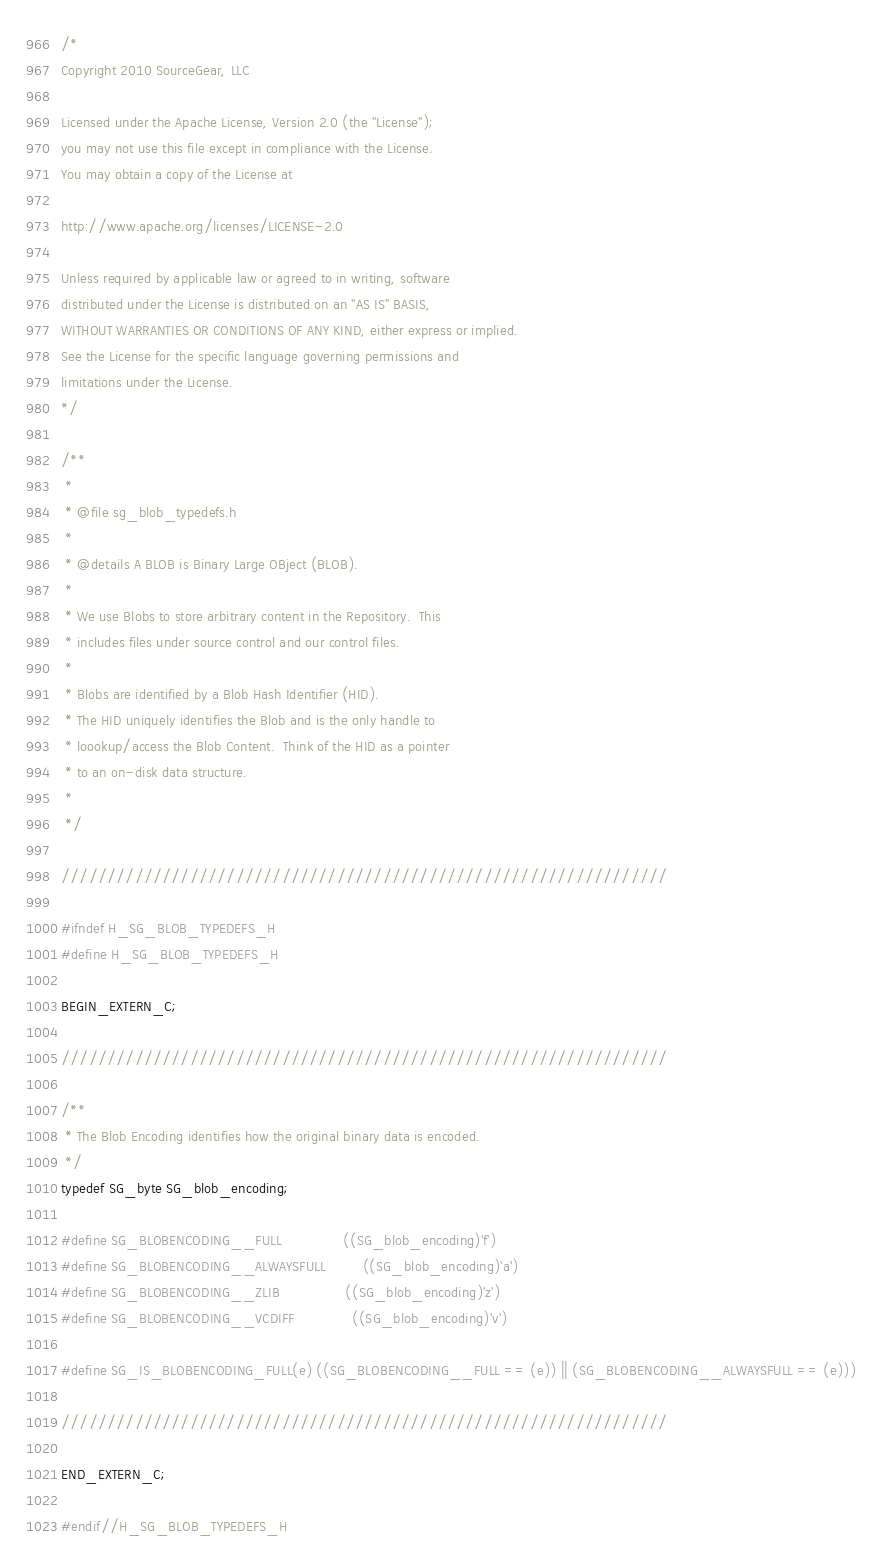<code> <loc_0><loc_0><loc_500><loc_500><_C_>/*
Copyright 2010 SourceGear, LLC

Licensed under the Apache License, Version 2.0 (the "License");
you may not use this file except in compliance with the License.
You may obtain a copy of the License at

http://www.apache.org/licenses/LICENSE-2.0

Unless required by applicable law or agreed to in writing, software
distributed under the License is distributed on an "AS IS" BASIS,
WITHOUT WARRANTIES OR CONDITIONS OF ANY KIND, either express or implied.
See the License for the specific language governing permissions and
limitations under the License.
*/

/**
 *
 * @file sg_blob_typedefs.h
 *
 * @details A BLOB is Binary Large OBject (BLOB).
 *
 * We use Blobs to store arbitrary content in the Repository.  This
 * includes files under source control and our control files.
 *
 * Blobs are identified by a Blob Hash Identifier (HID).
 * The HID uniquely identifies the Blob and is the only handle to
 * loookup/access the Blob Content.  Think of the HID as a pointer
 * to an on-disk data structure.
 *
 */

//////////////////////////////////////////////////////////////////

#ifndef H_SG_BLOB_TYPEDEFS_H
#define H_SG_BLOB_TYPEDEFS_H

BEGIN_EXTERN_C;

//////////////////////////////////////////////////////////////////

/**
 * The Blob Encoding identifies how the original binary data is encoded.
 */
typedef SG_byte SG_blob_encoding;

#define SG_BLOBENCODING__FULL               ((SG_blob_encoding)'f')
#define SG_BLOBENCODING__ALWAYSFULL         ((SG_blob_encoding)'a')
#define SG_BLOBENCODING__ZLIB		        ((SG_blob_encoding)'z')
#define SG_BLOBENCODING__VCDIFF			    ((SG_blob_encoding)'v')

#define SG_IS_BLOBENCODING_FULL(e) ((SG_BLOBENCODING__FULL == (e)) || (SG_BLOBENCODING__ALWAYSFULL == (e)))

//////////////////////////////////////////////////////////////////

END_EXTERN_C;

#endif//H_SG_BLOB_TYPEDEFS_H

</code> 